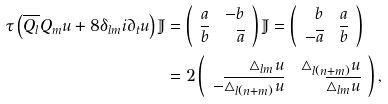Convert formula to latex. <formula><loc_0><loc_0><loc_500><loc_500>\tau \left ( \overline { Q _ { l } } { Q _ { m } } u + 8 \delta _ { l m } i \partial _ { t } u \right ) \mathbb { J } & = \left ( \begin{array} { r r } a & - b \\ \overline { b } & \overline { a } \\ \end{array} \right ) \mathbb { J } = \left ( \begin{array} { r r } b & a \\ - \overline { a } & \overline { b } \\ \end{array} \right ) \\ & = 2 \left ( \begin{array} { r r } \triangle _ { l m } u & \triangle _ { l ( n + m ) } u \\ - \overline { \triangle _ { l ( n + m ) } u } & \overline { \triangle _ { l m } u } \\ \end{array} \right ) ,</formula> 